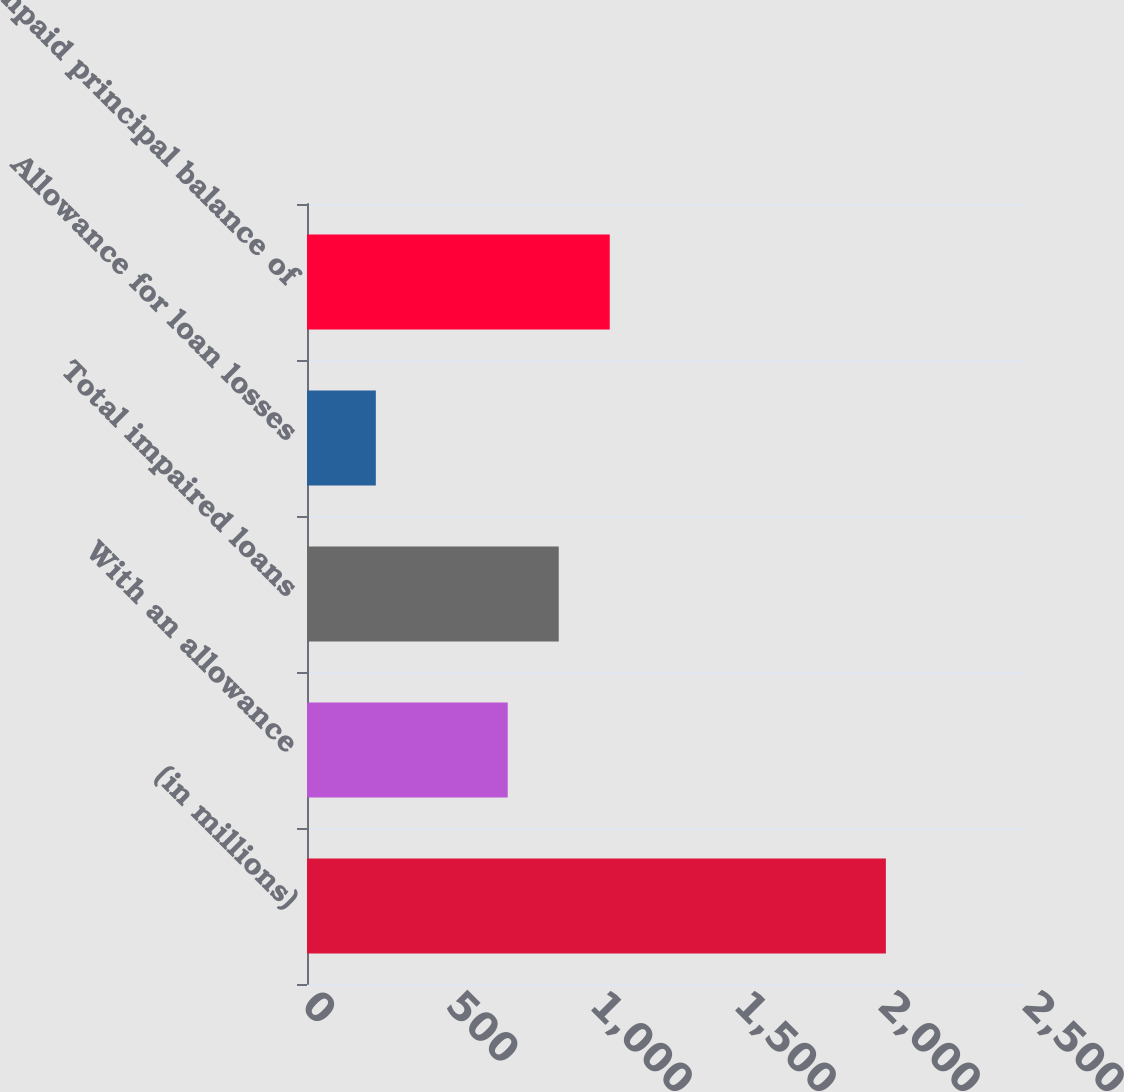Convert chart to OTSL. <chart><loc_0><loc_0><loc_500><loc_500><bar_chart><fcel>(in millions)<fcel>With an allowance<fcel>Total impaired loans<fcel>Allowance for loan losses<fcel>Unpaid principal balance of<nl><fcel>2010<fcel>697<fcel>874.1<fcel>239<fcel>1051.2<nl></chart> 